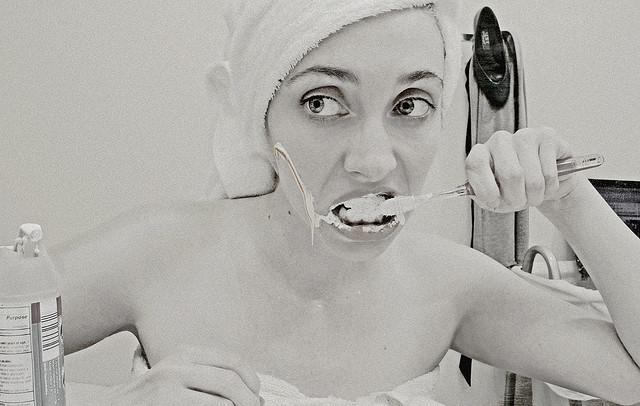What is the woman holding?
Keep it brief. Toothbrush. Is she looking in a mirror?
Short answer required. Yes. Is her head wrapped in a towel?
Be succinct. Yes. Is the girl wearing jewelry?
Answer briefly. No. Is the toothbrush in her mouth the right way?
Quick response, please. Yes. What did the woman do before brushing her teeth?
Short answer required. Shower. What is the person holding?
Answer briefly. Toothbrush. 